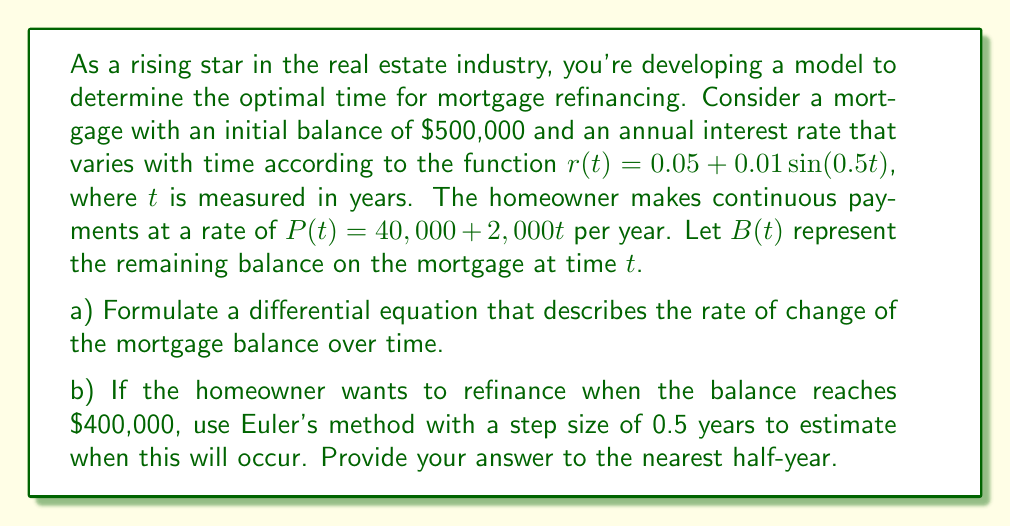Provide a solution to this math problem. Let's approach this problem step by step:

a) To formulate the differential equation, we need to consider the rate of change of the balance. The balance increases due to interest and decreases due to payments.

Rate of change = Interest accrual - Payments

This can be expressed as:

$$\frac{dB}{dt} = r(t)B(t) - P(t)$$

Substituting the given functions:

$$\frac{dB}{dt} = (0.05 + 0.01\sin(0.5t))B(t) - (40,000 + 2,000t)$$

This is our differential equation with time-dependent coefficients.

b) To solve this using Euler's method, we use the formula:

$$B_{n+1} = B_n + h\left(r(t_n)B_n - P(t_n)\right)$$

where $h = 0.5$ (our step size) and $B_0 = 500,000$ (initial balance).

Let's calculate step by step:

$t_0 = 0$:
$B_0 = 500,000$

$t_1 = 0.5$:
$B_1 = 500,000 + 0.5((0.05 + 0.01\sin(0))500,000 - (40,000 + 2,000(0)))$
$B_1 = 487,500$

$t_2 = 1$:
$B_2 = 487,500 + 0.5((0.05 + 0.01\sin(0.25))487,500 - (40,000 + 2,000(0.5)))$
$B_2 = 475,156.25$

$t_3 = 1.5$:
$B_3 = 475,156.25 + 0.5((0.05 + 0.01\sin(0.5))475,156.25 - (40,000 + 2,000(1)))$
$B_3 = 462,968.75$

$t_4 = 2$:
$B_4 = 462,968.75 + 0.5((0.05 + 0.01\sin(0.75))462,968.75 - (40,000 + 2,000(1.5)))$
$B_4 = 450,937.50$

$t_5 = 2.5$:
$B_5 = 450,937.50 + 0.5((0.05 + 0.01\sin(1))450,937.50 - (40,000 + 2,000(2)))$
$B_5 = 439,062.50$

$t_6 = 3$:
$B_6 = 439,062.50 + 0.5((0.05 + 0.01\sin(1.25))439,062.50 - (40,000 + 2,000(2.5)))$
$B_6 = 427,343.75$

$t_7 = 3.5$:
$B_7 = 427,343.75 + 0.5((0.05 + 0.01\sin(1.5))427,343.75 - (40,000 + 2,000(3)))$
$B_7 = 415,781.25$

$t_8 = 4$:
$B_8 = 415,781.25 + 0.5((0.05 + 0.01\sin(1.75))415,781.25 - (40,000 + 2,000(3.5)))$
$B_8 = 404,375.00$

The balance drops below $400,000 between $t_8$ and $t_9$. Therefore, to the nearest half-year, the refinancing should occur at $t = 4$ years.
Answer: The optimal time for refinancing, to the nearest half-year, is 4 years. 